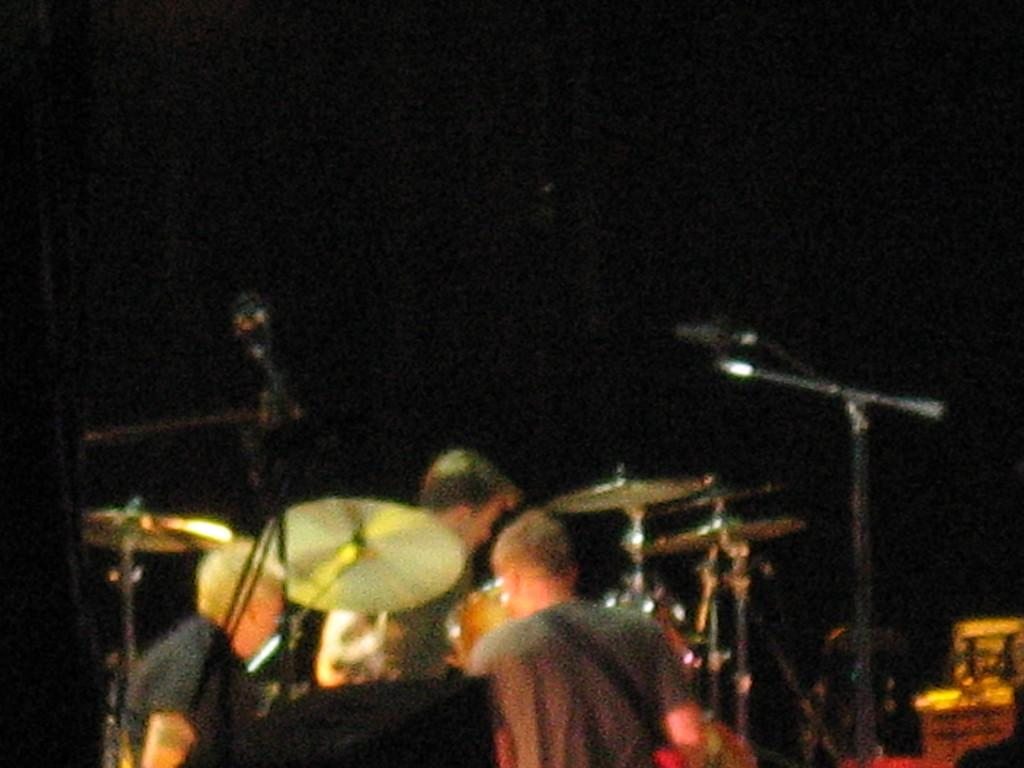What is happening in the picture? There is a group of people in the picture, and they are holding music instruments. What can be inferred about the activity in the picture? The people holding music instruments suggest that they might be playing or performing music. How would you describe the quality of the image? The picture is blurred. What color is the background of the picture? The background of the picture is black. What time of day is it in the picture, and what role does the ear play in the performance? The time of day cannot be determined from the image, and there is no ear present in the picture. The image only shows a group of people holding music instruments, and there is no indication of a specific time or the involvement of an ear in the performance. 